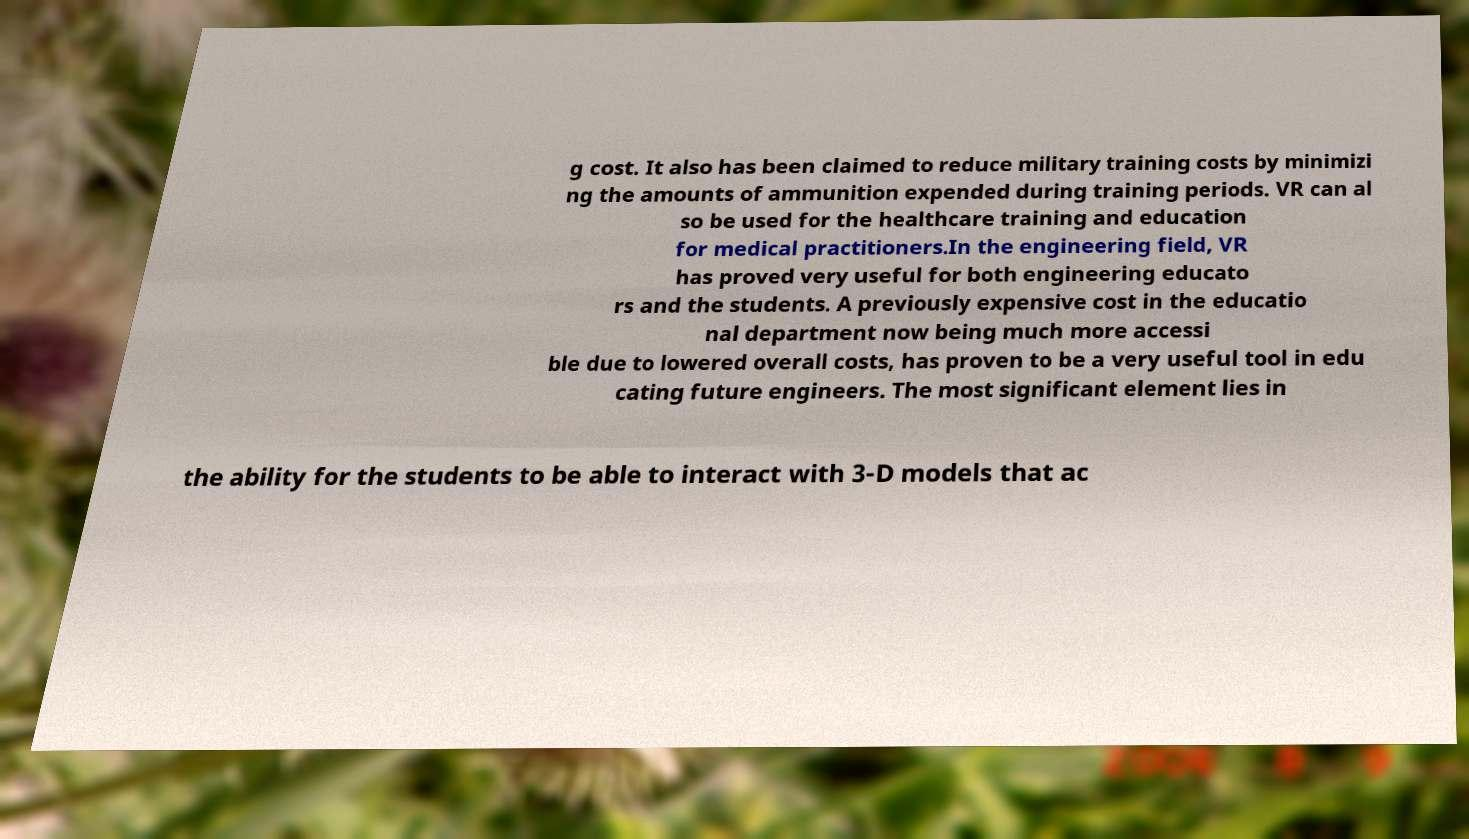I need the written content from this picture converted into text. Can you do that? g cost. It also has been claimed to reduce military training costs by minimizi ng the amounts of ammunition expended during training periods. VR can al so be used for the healthcare training and education for medical practitioners.In the engineering field, VR has proved very useful for both engineering educato rs and the students. A previously expensive cost in the educatio nal department now being much more accessi ble due to lowered overall costs, has proven to be a very useful tool in edu cating future engineers. The most significant element lies in the ability for the students to be able to interact with 3-D models that ac 